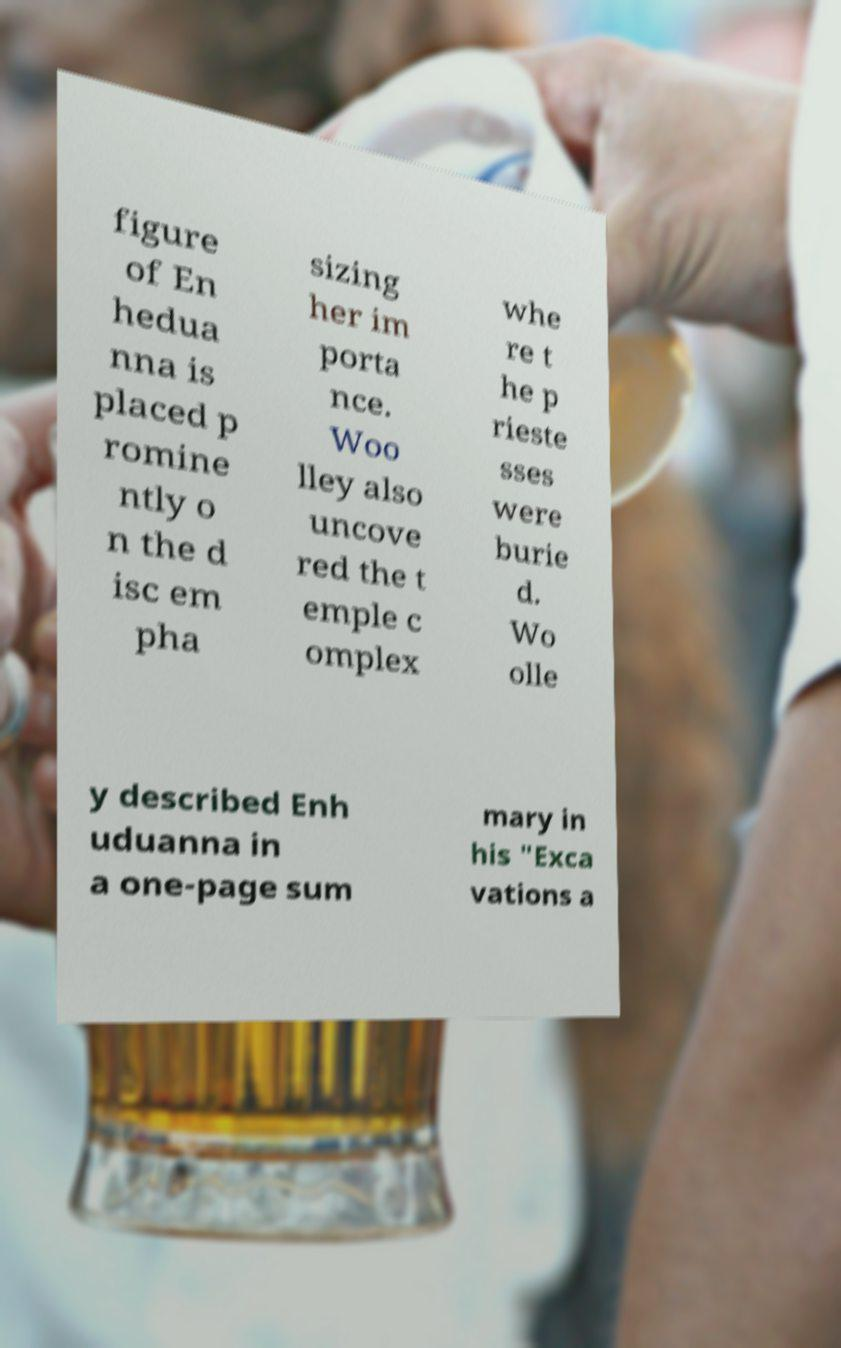Can you read and provide the text displayed in the image?This photo seems to have some interesting text. Can you extract and type it out for me? figure of En hedua nna is placed p romine ntly o n the d isc em pha sizing her im porta nce. Woo lley also uncove red the t emple c omplex whe re t he p rieste sses were burie d. Wo olle y described Enh uduanna in a one-page sum mary in his "Exca vations a 